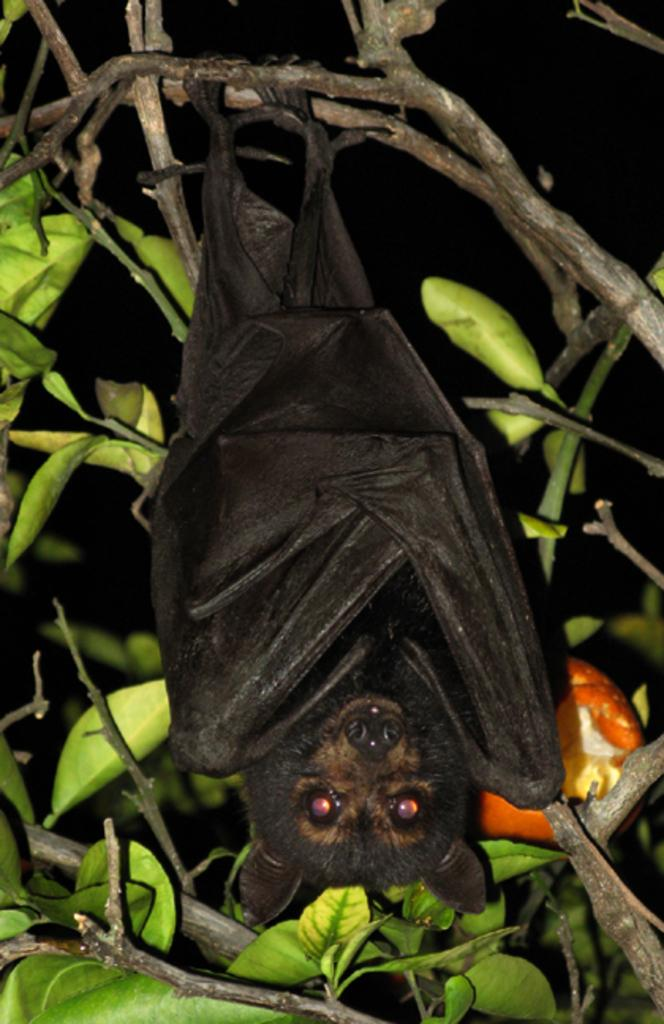What animal is present in the image? There is a bat in the image. How is the bat positioned in the image? The bat is hanging from a branch. What can be seen in the background of the image? There are leaves in the background of the image. What is the lighting condition in the image? The background of the image is dark. What type of station does the bat prefer during the holiday season? There is no information about the bat's preferences or the holiday season in the image. 